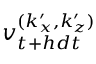Convert formula to latex. <formula><loc_0><loc_0><loc_500><loc_500>v _ { t + h d t } ^ { ( k _ { x } ^ { \prime } , k _ { z } ^ { \prime } ) }</formula> 